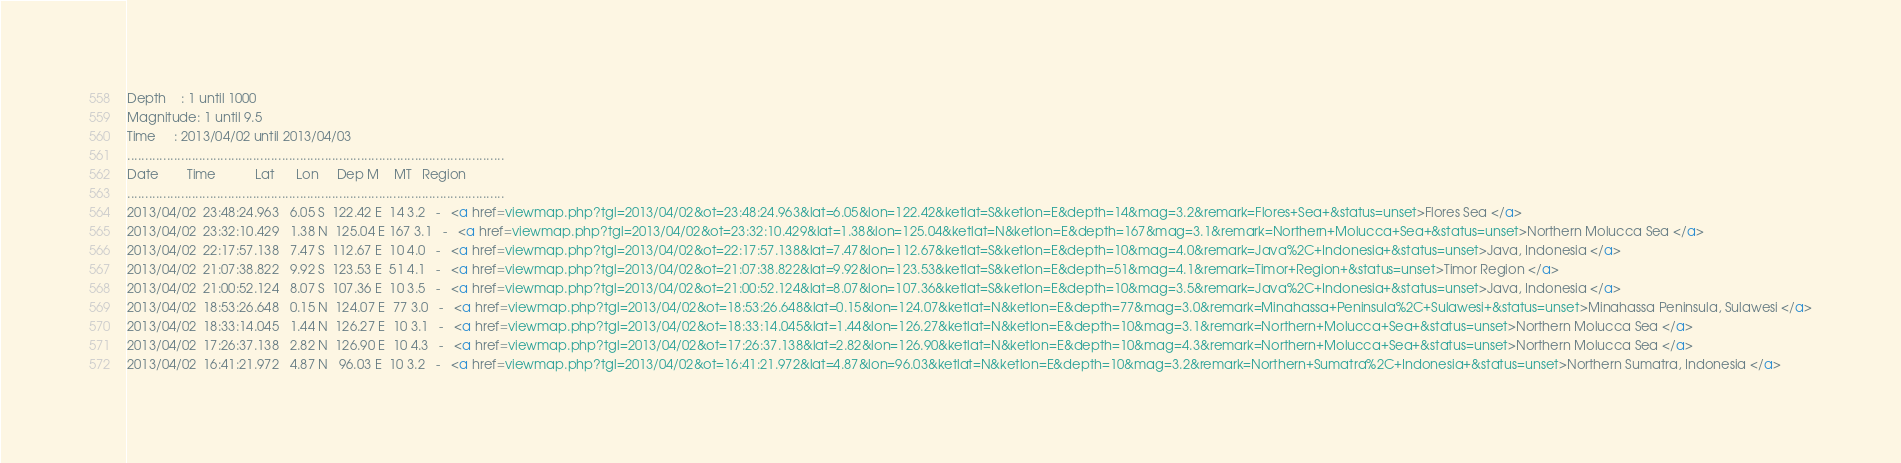<code> <loc_0><loc_0><loc_500><loc_500><_HTML_>Depth    : 1 until 1000
Magnitude: 1 until 9.5
Time     : 2013/04/02 until 2013/04/03
.........................................................................................................
Date        Time           Lat      Lon     Dep M    MT   Region
.........................................................................................................
2013/04/02  23:48:24.963   6.05 S  122.42 E  14 3.2   -   <a href=viewmap.php?tgl=2013/04/02&ot=23:48:24.963&lat=6.05&lon=122.42&ketlat=S&ketlon=E&depth=14&mag=3.2&remark=Flores+Sea+&status=unset>Flores Sea </a>
2013/04/02  23:32:10.429   1.38 N  125.04 E 167 3.1   -   <a href=viewmap.php?tgl=2013/04/02&ot=23:32:10.429&lat=1.38&lon=125.04&ketlat=N&ketlon=E&depth=167&mag=3.1&remark=Northern+Molucca+Sea+&status=unset>Northern Molucca Sea </a>
2013/04/02  22:17:57.138   7.47 S  112.67 E  10 4.0   -   <a href=viewmap.php?tgl=2013/04/02&ot=22:17:57.138&lat=7.47&lon=112.67&ketlat=S&ketlon=E&depth=10&mag=4.0&remark=Java%2C+Indonesia+&status=unset>Java, Indonesia </a>
2013/04/02  21:07:38.822   9.92 S  123.53 E  51 4.1   -   <a href=viewmap.php?tgl=2013/04/02&ot=21:07:38.822&lat=9.92&lon=123.53&ketlat=S&ketlon=E&depth=51&mag=4.1&remark=Timor+Region+&status=unset>Timor Region </a>
2013/04/02  21:00:52.124   8.07 S  107.36 E  10 3.5   -   <a href=viewmap.php?tgl=2013/04/02&ot=21:00:52.124&lat=8.07&lon=107.36&ketlat=S&ketlon=E&depth=10&mag=3.5&remark=Java%2C+Indonesia+&status=unset>Java, Indonesia </a>
2013/04/02  18:53:26.648   0.15 N  124.07 E  77 3.0   -   <a href=viewmap.php?tgl=2013/04/02&ot=18:53:26.648&lat=0.15&lon=124.07&ketlat=N&ketlon=E&depth=77&mag=3.0&remark=Minahassa+Peninsula%2C+Sulawesi+&status=unset>Minahassa Peninsula, Sulawesi </a>
2013/04/02  18:33:14.045   1.44 N  126.27 E  10 3.1   -   <a href=viewmap.php?tgl=2013/04/02&ot=18:33:14.045&lat=1.44&lon=126.27&ketlat=N&ketlon=E&depth=10&mag=3.1&remark=Northern+Molucca+Sea+&status=unset>Northern Molucca Sea </a>
2013/04/02  17:26:37.138   2.82 N  126.90 E  10 4.3   -   <a href=viewmap.php?tgl=2013/04/02&ot=17:26:37.138&lat=2.82&lon=126.90&ketlat=N&ketlon=E&depth=10&mag=4.3&remark=Northern+Molucca+Sea+&status=unset>Northern Molucca Sea </a>
2013/04/02  16:41:21.972   4.87 N   96.03 E  10 3.2   -   <a href=viewmap.php?tgl=2013/04/02&ot=16:41:21.972&lat=4.87&lon=96.03&ketlat=N&ketlon=E&depth=10&mag=3.2&remark=Northern+Sumatra%2C+Indonesia+&status=unset>Northern Sumatra, Indonesia </a></code> 